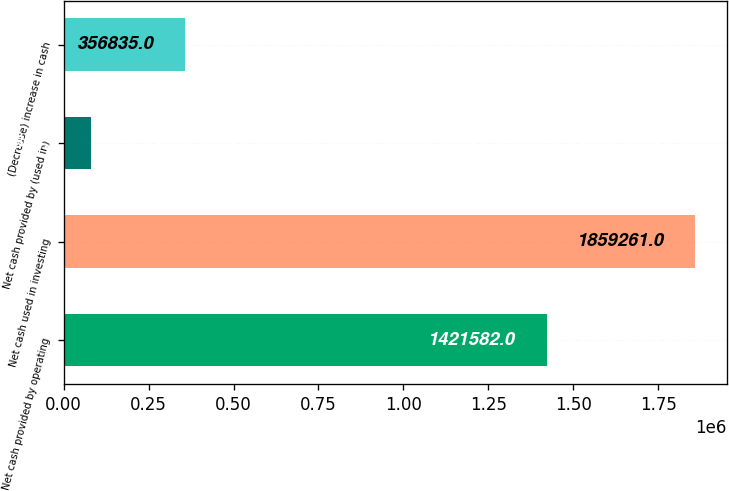Convert chart. <chart><loc_0><loc_0><loc_500><loc_500><bar_chart><fcel>Net cash provided by operating<fcel>Net cash used in investing<fcel>Net cash provided by (used in)<fcel>(Decrease) increase in cash<nl><fcel>1.42158e+06<fcel>1.85926e+06<fcel>80844<fcel>356835<nl></chart> 